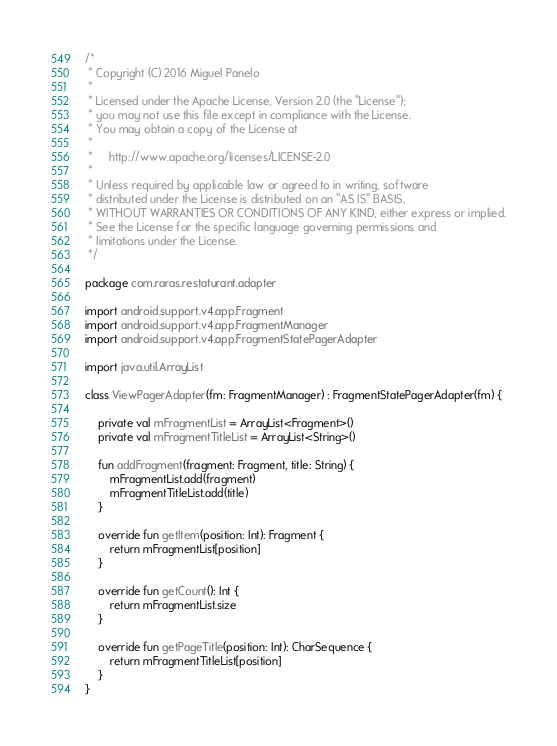Convert code to text. <code><loc_0><loc_0><loc_500><loc_500><_Kotlin_>/*
 * Copyright (C) 2016 Miguel Panelo
 *
 * Licensed under the Apache License, Version 2.0 (the "License");
 * you may not use this file except in compliance with the License.
 * You may obtain a copy of the License at
 *
 *     http://www.apache.org/licenses/LICENSE-2.0
 *
 * Unless required by applicable law or agreed to in writing, software
 * distributed under the License is distributed on an "AS IS" BASIS,
 * WITHOUT WARRANTIES OR CONDITIONS OF ANY KIND, either express or implied.
 * See the License for the specific language governing permissions and
 * limitations under the License.
 */

package com.raras.restaturant.adapter

import android.support.v4.app.Fragment
import android.support.v4.app.FragmentManager
import android.support.v4.app.FragmentStatePagerAdapter

import java.util.ArrayList

class ViewPagerAdapter(fm: FragmentManager) : FragmentStatePagerAdapter(fm) {

    private val mFragmentList = ArrayList<Fragment>()
    private val mFragmentTitleList = ArrayList<String>()

    fun addFragment(fragment: Fragment, title: String) {
        mFragmentList.add(fragment)
        mFragmentTitleList.add(title)
    }

    override fun getItem(position: Int): Fragment {
        return mFragmentList[position]
    }

    override fun getCount(): Int {
        return mFragmentList.size
    }

    override fun getPageTitle(position: Int): CharSequence {
        return mFragmentTitleList[position]
    }
}
</code> 